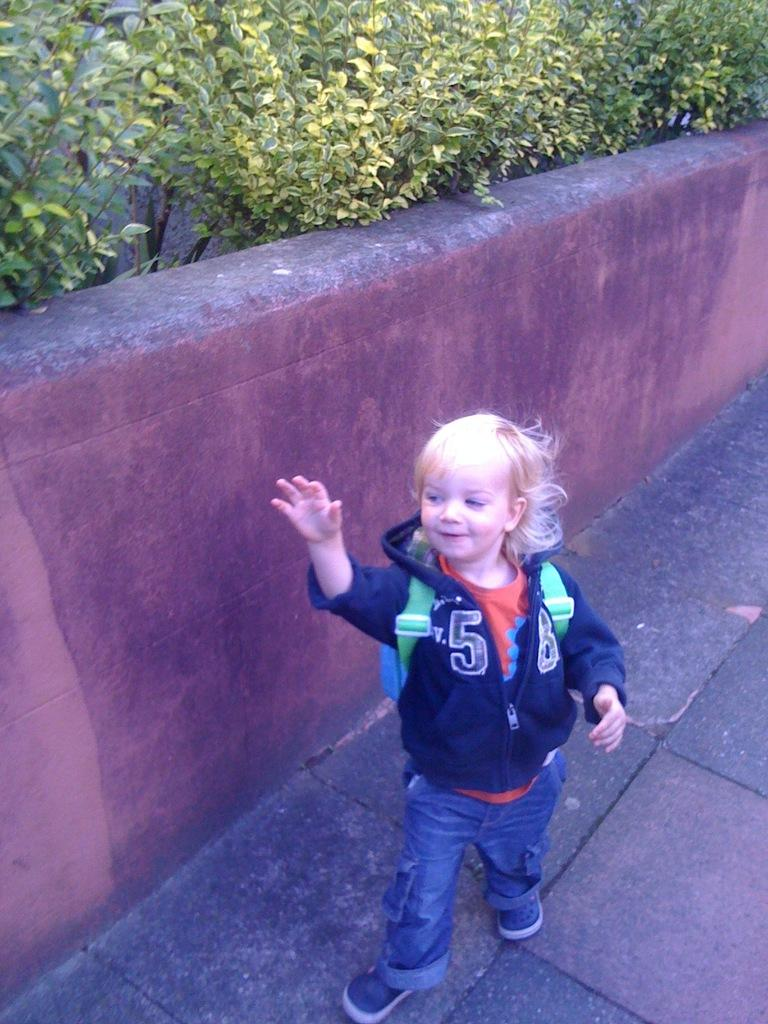<image>
Create a compact narrative representing the image presented. A young child wearing jeans and a sweatshirt with the number 5 on it is walking on a sidewalk. 